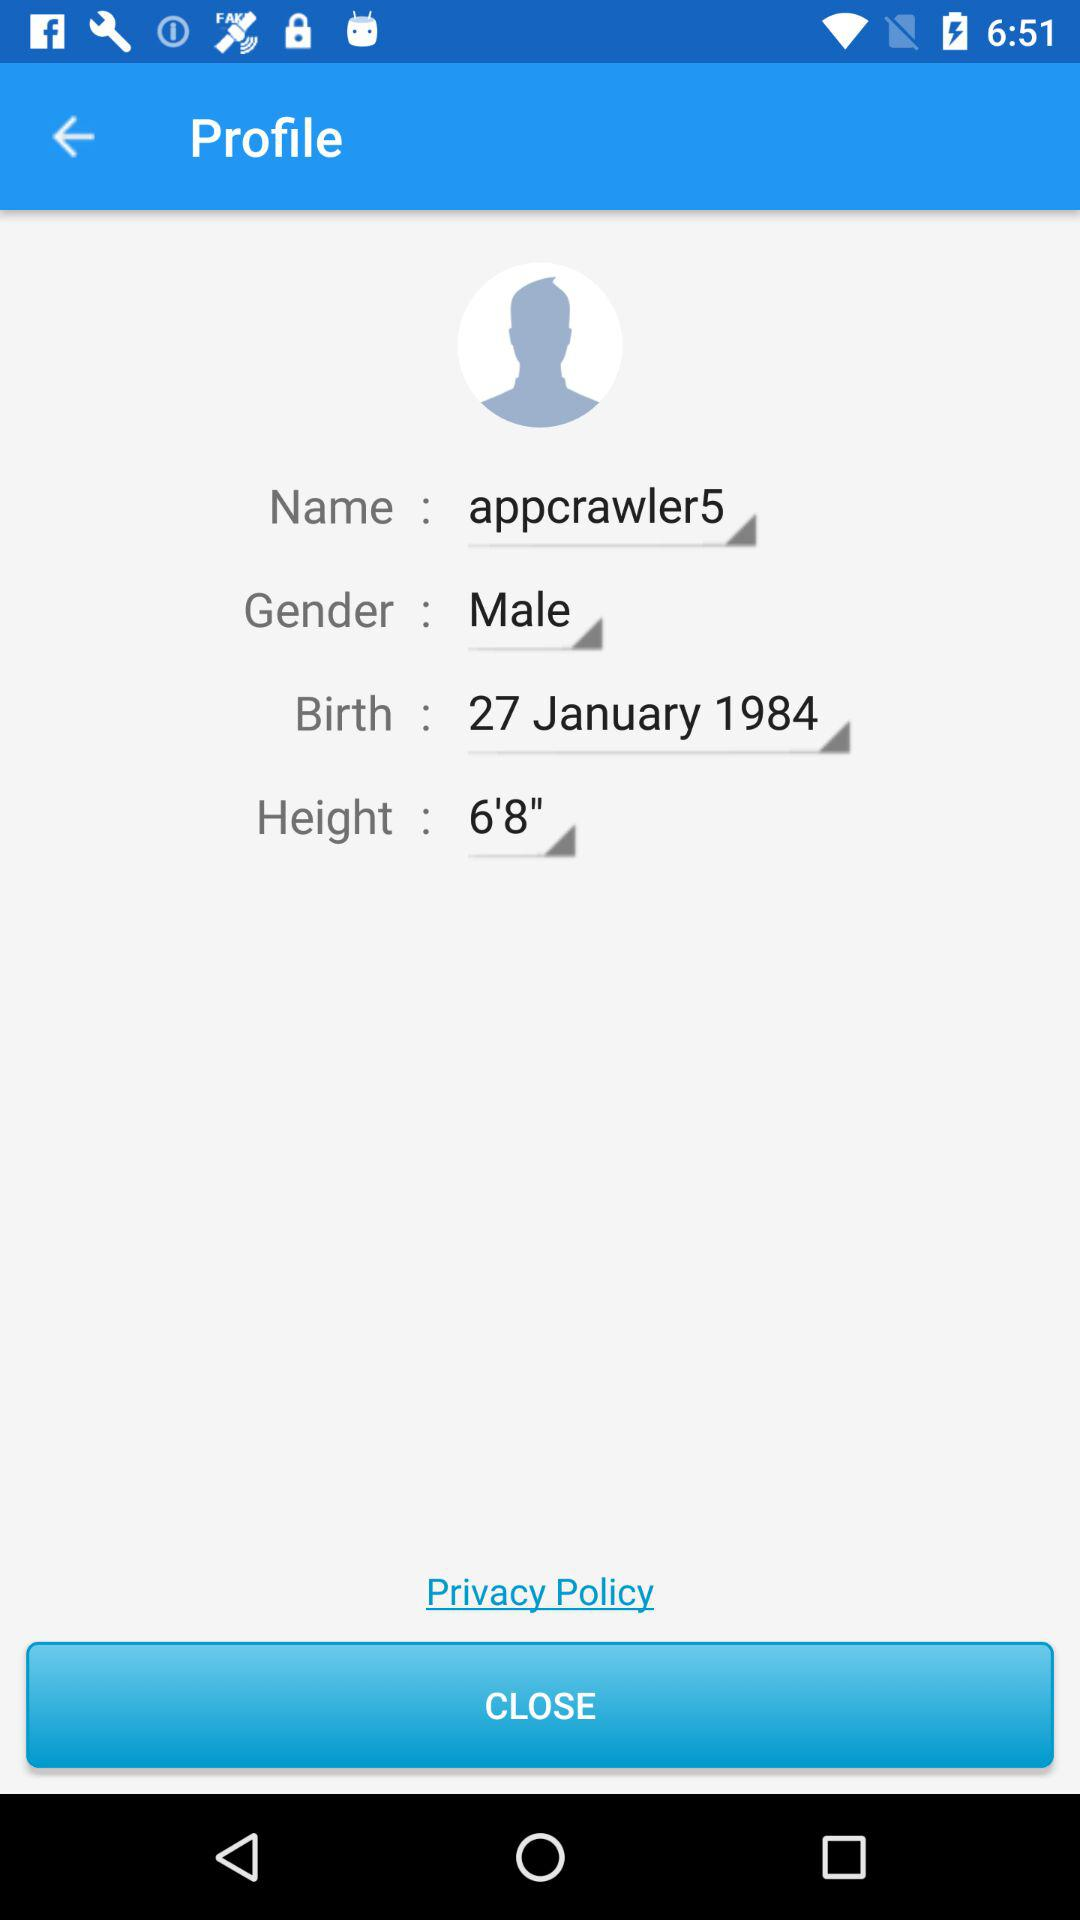What is the date of birth? The date of birth is January 27, 1984. 